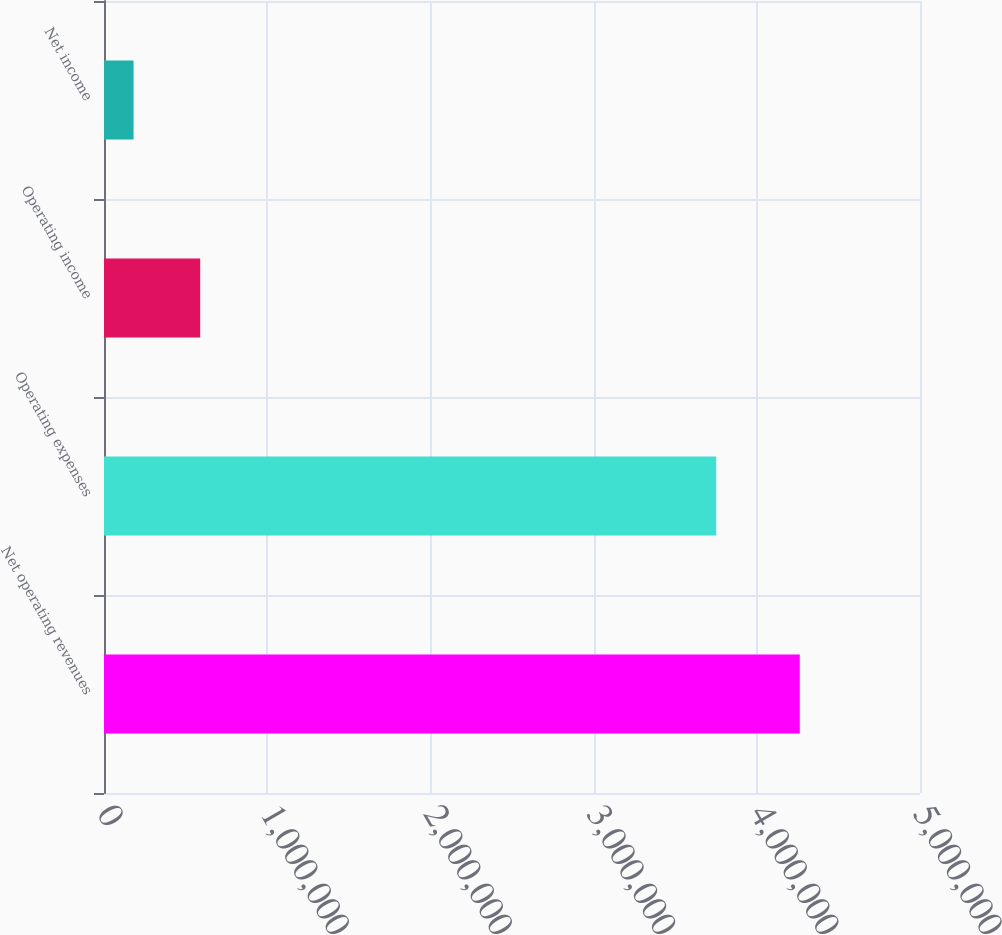<chart> <loc_0><loc_0><loc_500><loc_500><bar_chart><fcel>Net operating revenues<fcel>Operating expenses<fcel>Operating income<fcel>Net income<nl><fcel>4.26336e+06<fcel>3.75116e+06<fcel>589391<fcel>181172<nl></chart> 